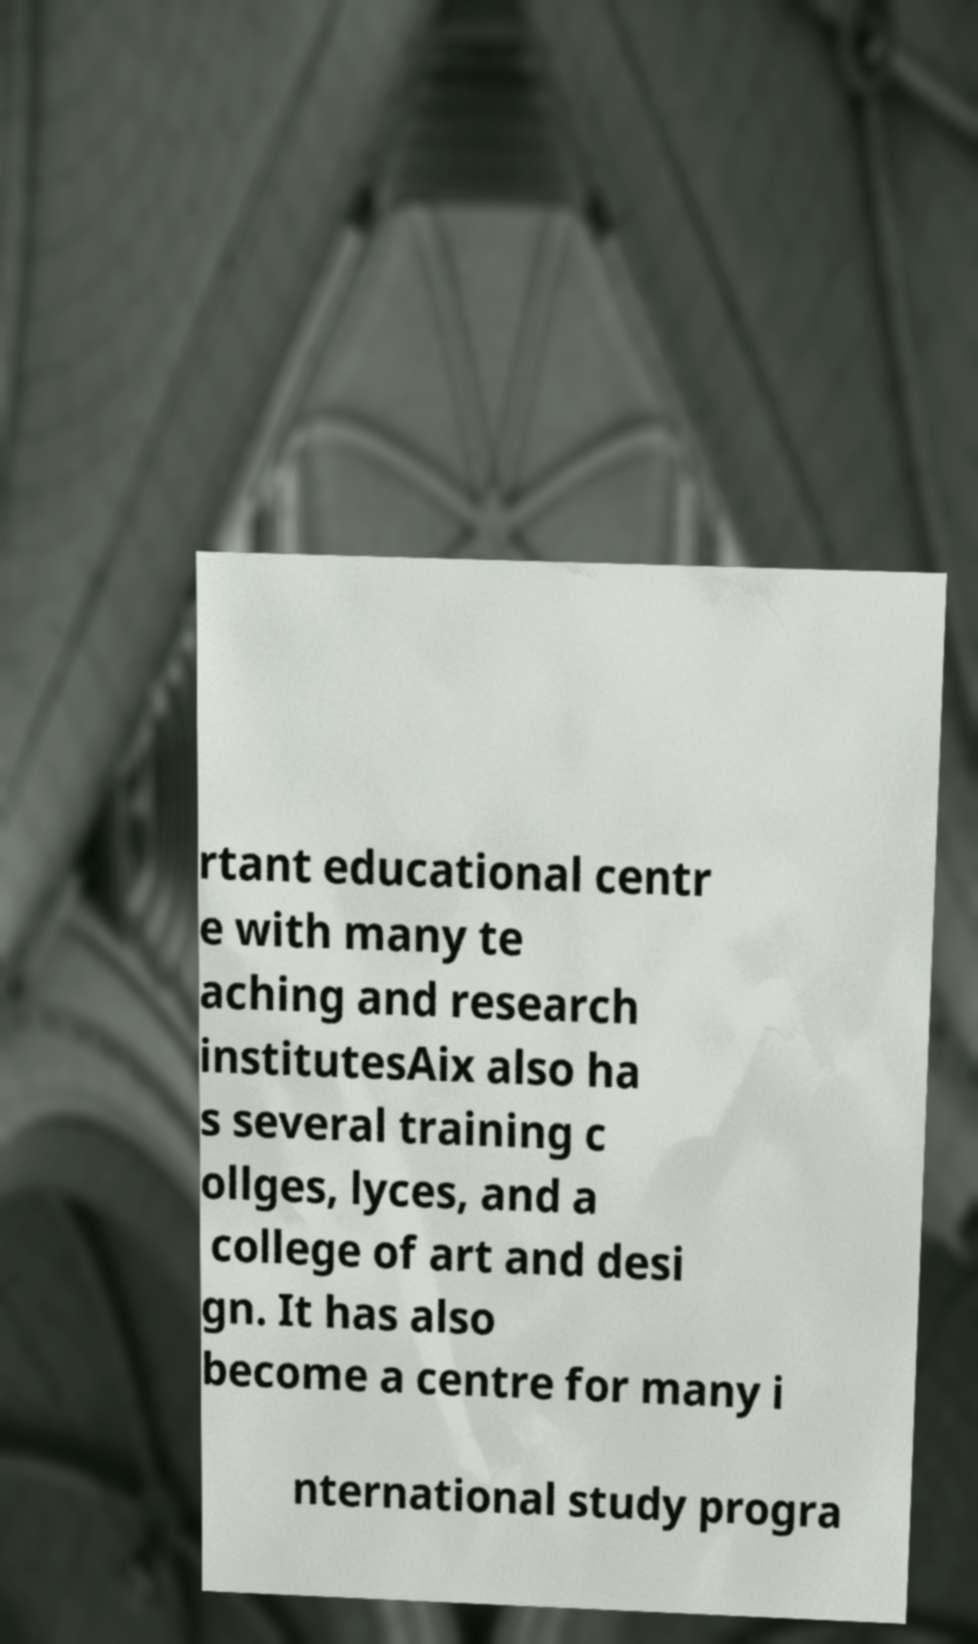Please read and relay the text visible in this image. What does it say? rtant educational centr e with many te aching and research institutesAix also ha s several training c ollges, lyces, and a college of art and desi gn. It has also become a centre for many i nternational study progra 